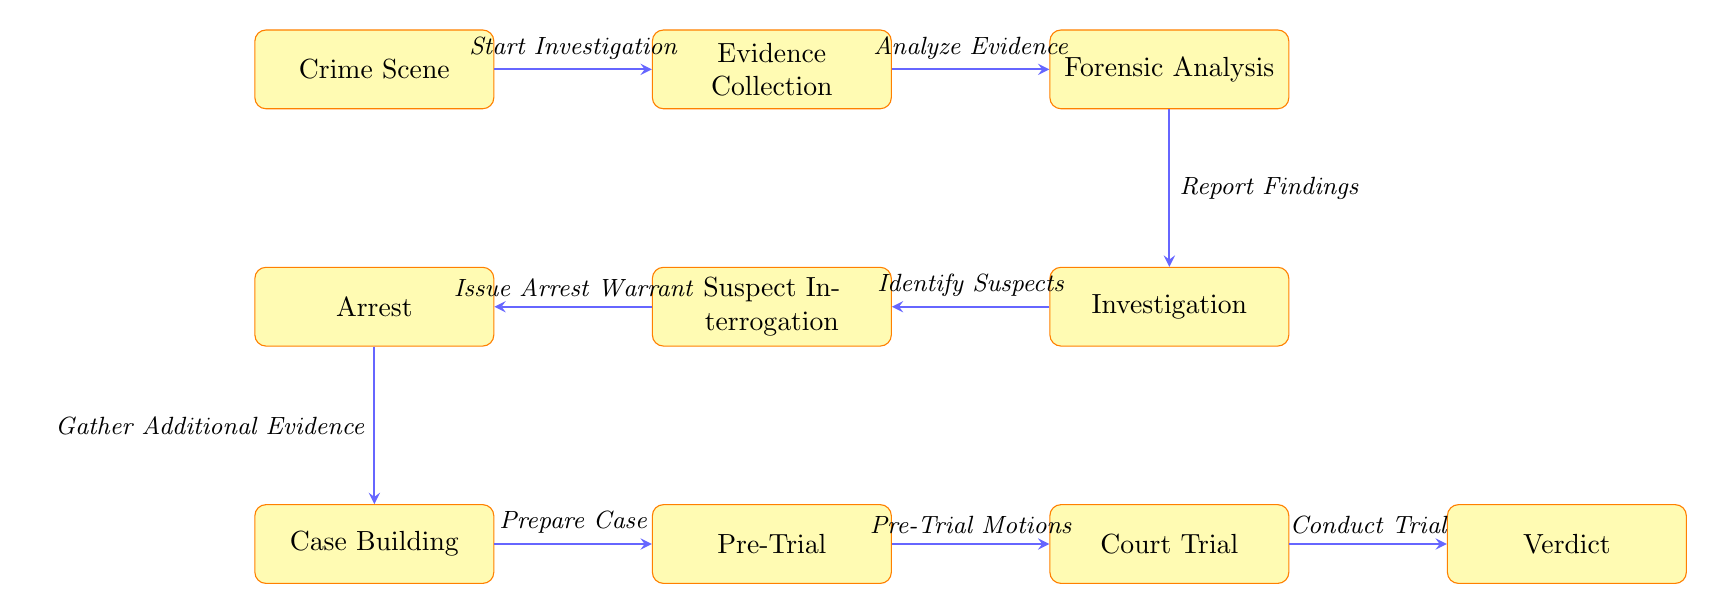What is the first step in the investigation process? The diagram indicates that the first step is labeled as "Crime Scene," which serves as the starting point of the process.
Answer: Crime Scene How many processes are listed in the diagram? By counting all the distinct rectangles in the diagram, we find there are a total of ten individual processes involved.
Answer: 10 Which process comes before "Forensic Analysis"? Looking at the flow of arrows, the process labeled as "Evidence Collection" directly precedes "Forensic Analysis" in the sequence.
Answer: Evidence Collection What action is taken after the "Investigation" step? The diagram shows that the next step after "Investigation" is "Suspect Interrogation," indicating the sequence of actions in the investigation process.
Answer: Suspect Interrogation What is the final outcome of the investigation process? The last step, or the endpoint in the diagram, is noted as "Verdict," which represents the conclusion of the legal process.
Answer: Verdict How does "Arrest" relate to "Suspect Interrogation"? The arrow indicates that "Suspect Interrogation" leads to "Arrest," showing that issuing an arrest warrant is the action taken following the interrogation of suspects.
Answer: Leads to What is the purpose of the "Pre-Trial" process? In the context of the diagram, "Pre-Trial" serves as a preparation phase where motions are handled before proceeding to the courtroom.
Answer: Prepare Case What stage involves gathering additional evidence? The diagram denotes that the stage for gathering additional evidence is "Case Building," which is positioned after the arrest step.
Answer: Case Building Which two processes are parallel in the diagram? "Forensic Analysis" and "Investigation" are depicted at the same level but in different vertical positions, indicating they run concurrently in the investigation process.
Answer: Forensic Analysis and Investigation 